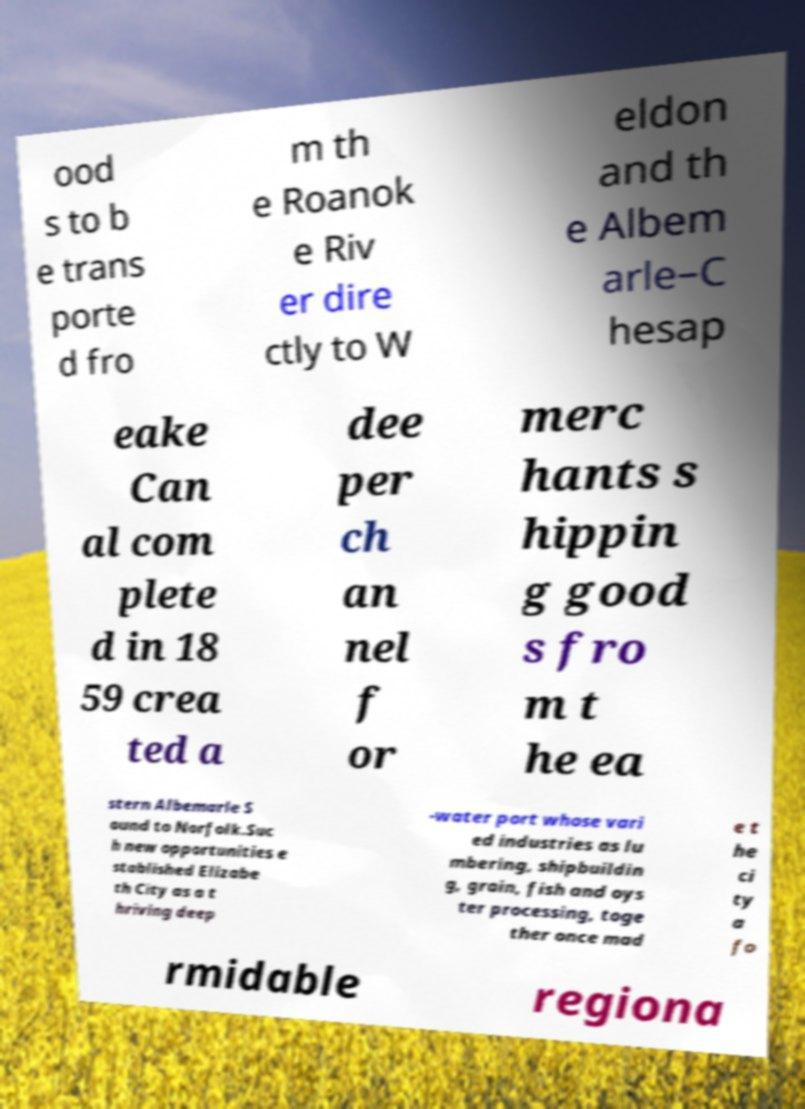Could you assist in decoding the text presented in this image and type it out clearly? ood s to b e trans porte d fro m th e Roanok e Riv er dire ctly to W eldon and th e Albem arle–C hesap eake Can al com plete d in 18 59 crea ted a dee per ch an nel f or merc hants s hippin g good s fro m t he ea stern Albemarle S ound to Norfolk.Suc h new opportunities e stablished Elizabe th City as a t hriving deep -water port whose vari ed industries as lu mbering, shipbuildin g, grain, fish and oys ter processing, toge ther once mad e t he ci ty a fo rmidable regiona 